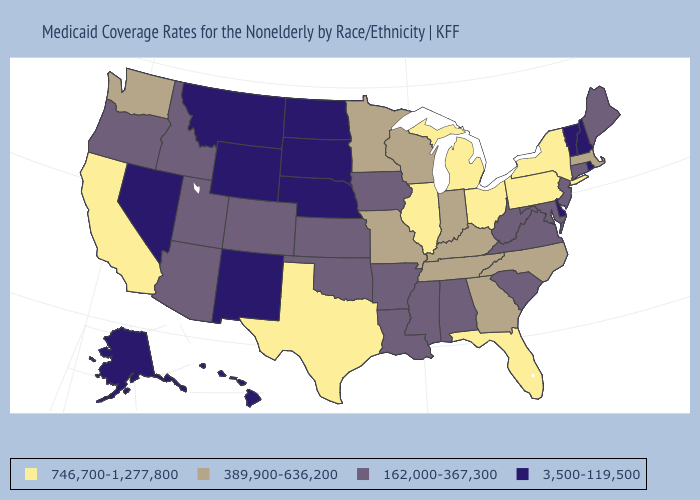What is the value of Vermont?
Answer briefly. 3,500-119,500. Does Michigan have a higher value than North Carolina?
Quick response, please. Yes. Is the legend a continuous bar?
Keep it brief. No. Among the states that border Alabama , which have the lowest value?
Keep it brief. Mississippi. What is the lowest value in states that border Connecticut?
Concise answer only. 3,500-119,500. Which states hav the highest value in the Northeast?
Write a very short answer. New York, Pennsylvania. What is the value of Missouri?
Short answer required. 389,900-636,200. Is the legend a continuous bar?
Concise answer only. No. Does North Carolina have the highest value in the USA?
Write a very short answer. No. Name the states that have a value in the range 389,900-636,200?
Short answer required. Georgia, Indiana, Kentucky, Massachusetts, Minnesota, Missouri, North Carolina, Tennessee, Washington, Wisconsin. What is the highest value in the South ?
Answer briefly. 746,700-1,277,800. Does Connecticut have the highest value in the Northeast?
Concise answer only. No. Does Washington have a lower value than Oregon?
Write a very short answer. No. What is the value of Vermont?
Write a very short answer. 3,500-119,500. 